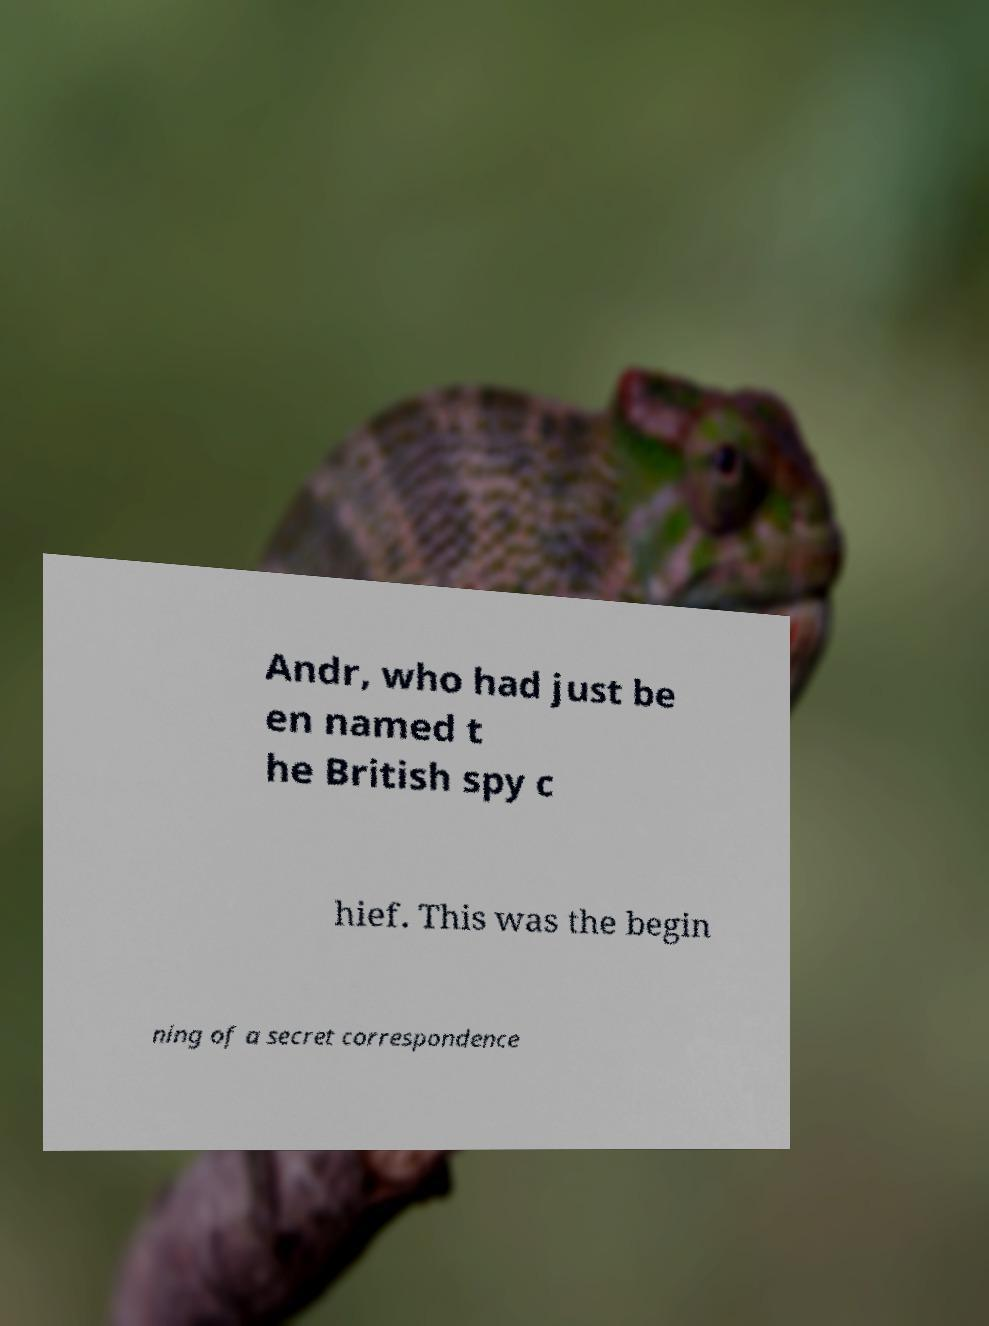What messages or text are displayed in this image? I need them in a readable, typed format. Andr, who had just be en named t he British spy c hief. This was the begin ning of a secret correspondence 